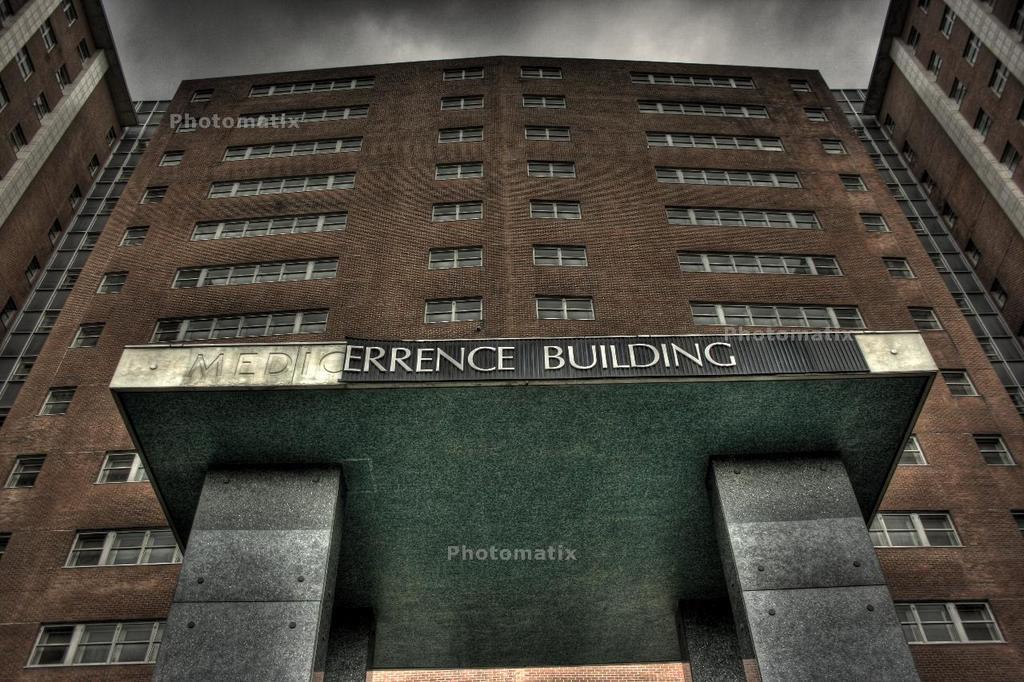Can you describe this image briefly? In this image we can see a building with windows, pillars and text and on the top there is a sky with clouds. 